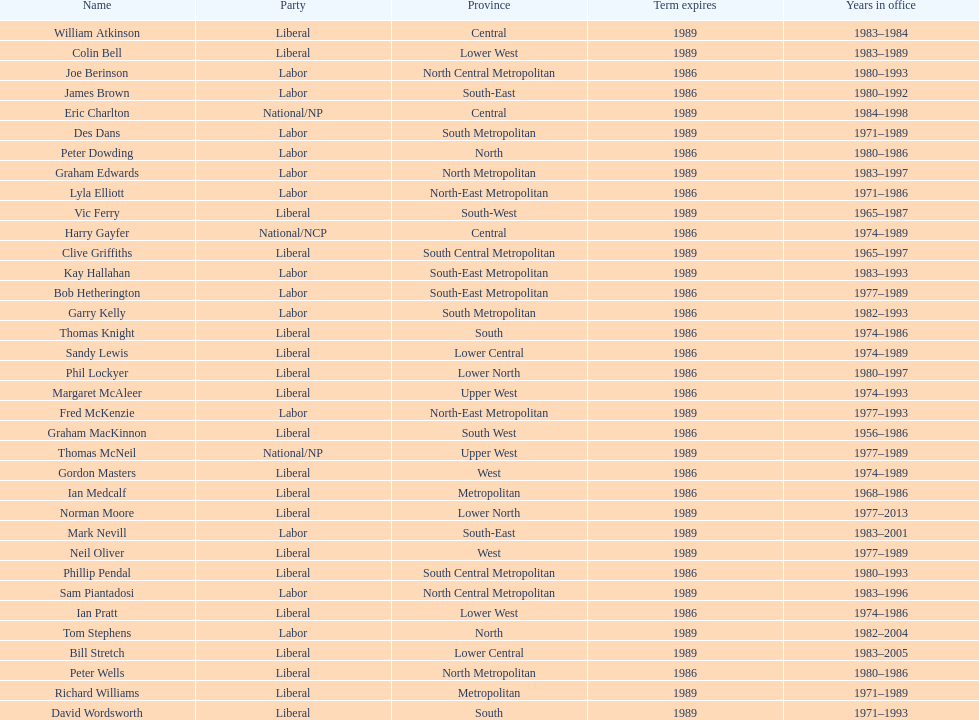Write the full table. {'header': ['Name', 'Party', 'Province', 'Term expires', 'Years in office'], 'rows': [['William Atkinson', 'Liberal', 'Central', '1989', '1983–1984'], ['Colin Bell', 'Liberal', 'Lower West', '1989', '1983–1989'], ['Joe Berinson', 'Labor', 'North Central Metropolitan', '1986', '1980–1993'], ['James Brown', 'Labor', 'South-East', '1986', '1980–1992'], ['Eric Charlton', 'National/NP', 'Central', '1989', '1984–1998'], ['Des Dans', 'Labor', 'South Metropolitan', '1989', '1971–1989'], ['Peter Dowding', 'Labor', 'North', '1986', '1980–1986'], ['Graham Edwards', 'Labor', 'North Metropolitan', '1989', '1983–1997'], ['Lyla Elliott', 'Labor', 'North-East Metropolitan', '1986', '1971–1986'], ['Vic Ferry', 'Liberal', 'South-West', '1989', '1965–1987'], ['Harry Gayfer', 'National/NCP', 'Central', '1986', '1974–1989'], ['Clive Griffiths', 'Liberal', 'South Central Metropolitan', '1989', '1965–1997'], ['Kay Hallahan', 'Labor', 'South-East Metropolitan', '1989', '1983–1993'], ['Bob Hetherington', 'Labor', 'South-East Metropolitan', '1986', '1977–1989'], ['Garry Kelly', 'Labor', 'South Metropolitan', '1986', '1982–1993'], ['Thomas Knight', 'Liberal', 'South', '1986', '1974–1986'], ['Sandy Lewis', 'Liberal', 'Lower Central', '1986', '1974–1989'], ['Phil Lockyer', 'Liberal', 'Lower North', '1986', '1980–1997'], ['Margaret McAleer', 'Liberal', 'Upper West', '1986', '1974–1993'], ['Fred McKenzie', 'Labor', 'North-East Metropolitan', '1989', '1977–1993'], ['Graham MacKinnon', 'Liberal', 'South West', '1986', '1956–1986'], ['Thomas McNeil', 'National/NP', 'Upper West', '1989', '1977–1989'], ['Gordon Masters', 'Liberal', 'West', '1986', '1974–1989'], ['Ian Medcalf', 'Liberal', 'Metropolitan', '1986', '1968–1986'], ['Norman Moore', 'Liberal', 'Lower North', '1989', '1977–2013'], ['Mark Nevill', 'Labor', 'South-East', '1989', '1983–2001'], ['Neil Oliver', 'Liberal', 'West', '1989', '1977–1989'], ['Phillip Pendal', 'Liberal', 'South Central Metropolitan', '1986', '1980–1993'], ['Sam Piantadosi', 'Labor', 'North Central Metropolitan', '1989', '1983–1996'], ['Ian Pratt', 'Liberal', 'Lower West', '1986', '1974–1986'], ['Tom Stephens', 'Labor', 'North', '1989', '1982–2004'], ['Bill Stretch', 'Liberal', 'Lower Central', '1989', '1983–2005'], ['Peter Wells', 'Liberal', 'North Metropolitan', '1986', '1980–1986'], ['Richard Williams', 'Liberal', 'Metropolitan', '1989', '1971–1989'], ['David Wordsworth', 'Liberal', 'South', '1989', '1971–1993']]} Who served the minimum duration in office? William Atkinson. 